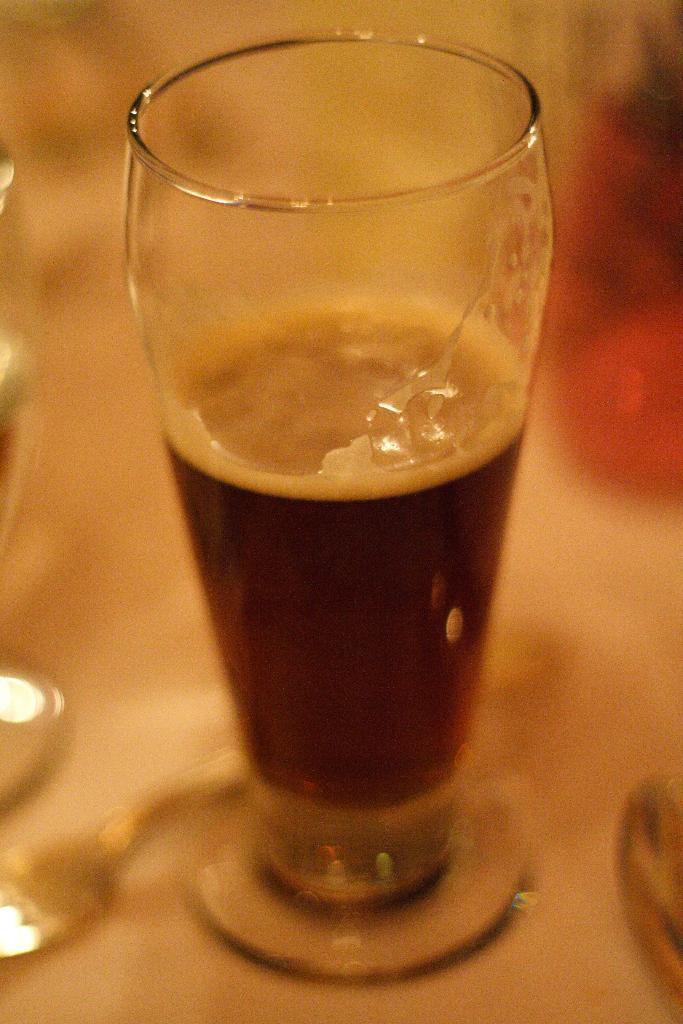Describe this image in one or two sentences. In this picture we can see glass with drink and objects on the platform. In the background of the image it is blurry. 